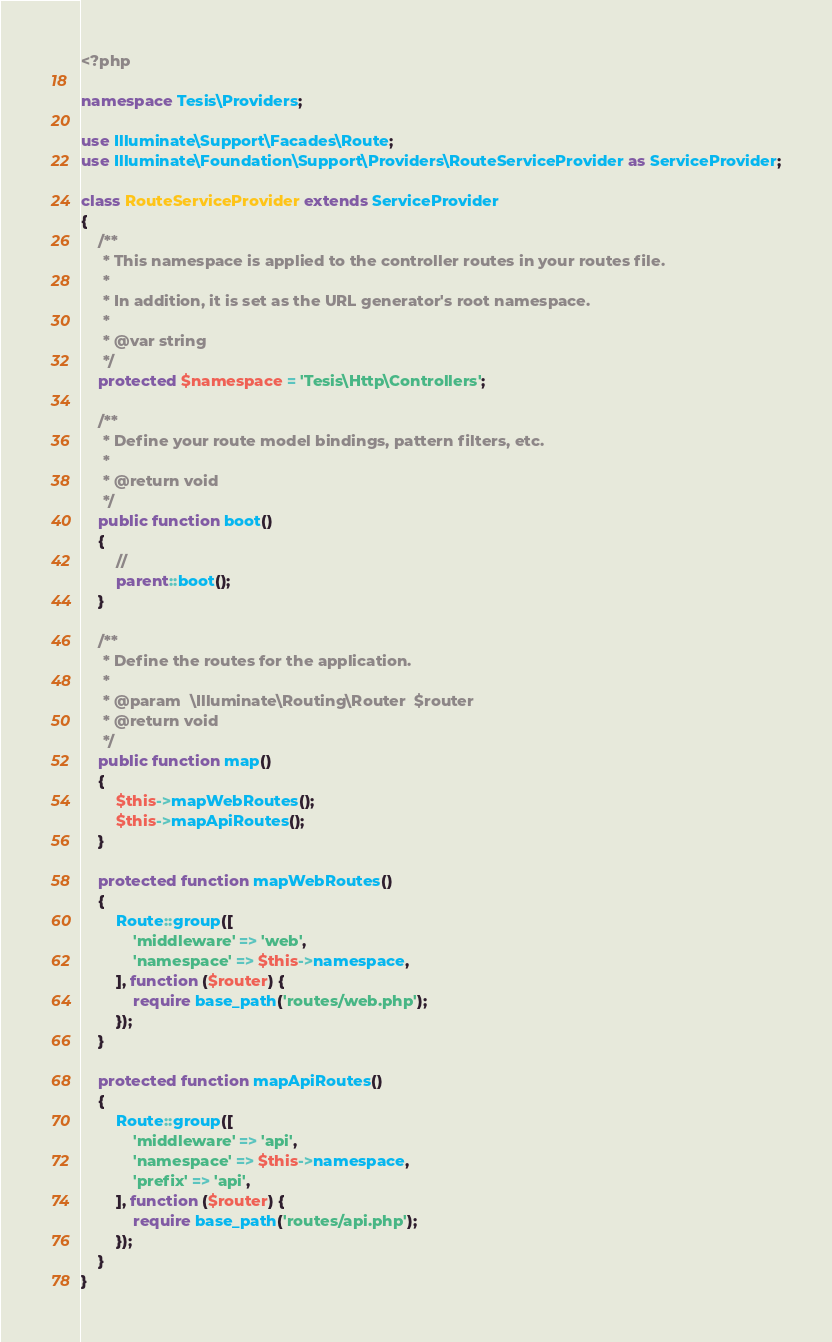<code> <loc_0><loc_0><loc_500><loc_500><_PHP_><?php

namespace Tesis\Providers;

use Illuminate\Support\Facades\Route;
use Illuminate\Foundation\Support\Providers\RouteServiceProvider as ServiceProvider;

class RouteServiceProvider extends ServiceProvider
{
    /**
     * This namespace is applied to the controller routes in your routes file.
     *
     * In addition, it is set as the URL generator's root namespace.
     *
     * @var string
     */
    protected $namespace = 'Tesis\Http\Controllers';

    /**
     * Define your route model bindings, pattern filters, etc.
     *
     * @return void
     */
    public function boot()
    {
        //
        parent::boot();
    }

    /**
     * Define the routes for the application.
     *
     * @param  \Illuminate\Routing\Router  $router
     * @return void
     */
    public function map()
    {
        $this->mapWebRoutes();
        $this->mapApiRoutes();
    }

    protected function mapWebRoutes()
    {
        Route::group([
            'middleware' => 'web',
            'namespace' => $this->namespace,
        ], function ($router) {
            require base_path('routes/web.php');
        });
    }

    protected function mapApiRoutes()
    {
        Route::group([
            'middleware' => 'api',
            'namespace' => $this->namespace,
            'prefix' => 'api',
        ], function ($router) {
            require base_path('routes/api.php');
        });
    }
}
</code> 